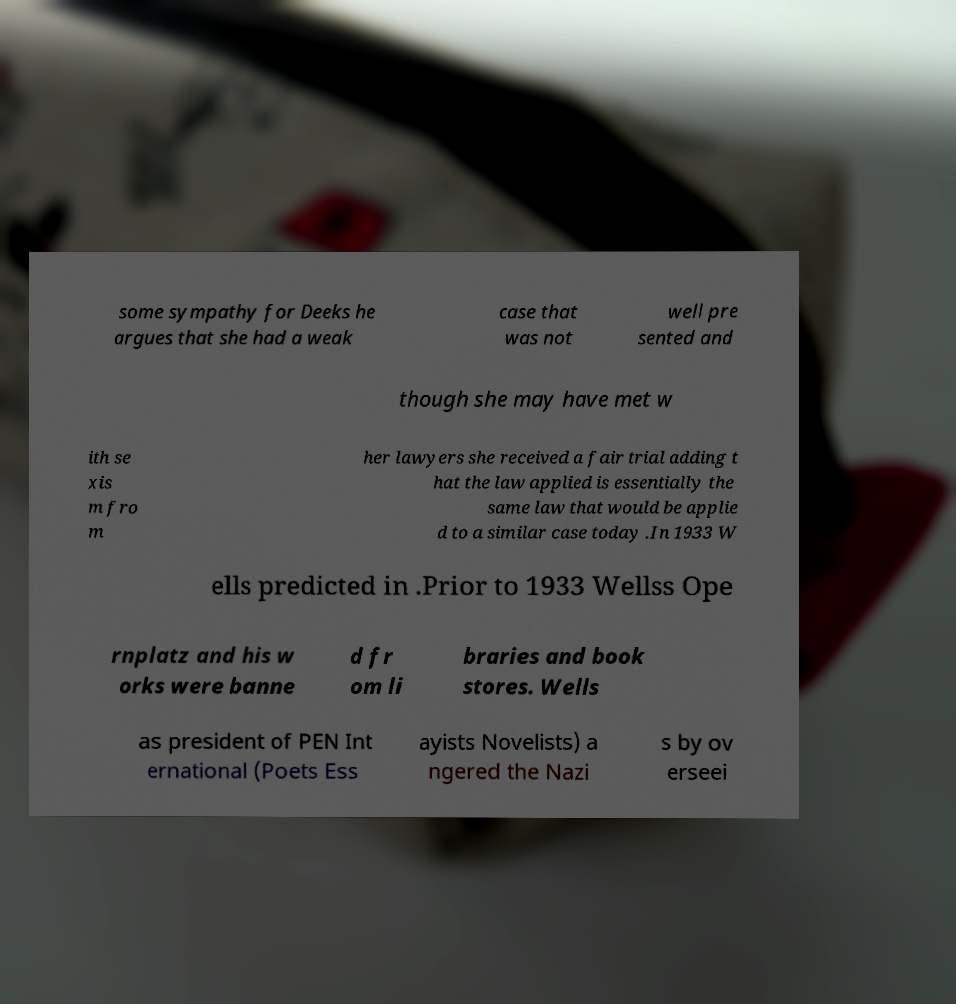Can you read and provide the text displayed in the image?This photo seems to have some interesting text. Can you extract and type it out for me? some sympathy for Deeks he argues that she had a weak case that was not well pre sented and though she may have met w ith se xis m fro m her lawyers she received a fair trial adding t hat the law applied is essentially the same law that would be applie d to a similar case today .In 1933 W ells predicted in .Prior to 1933 Wellss Ope rnplatz and his w orks were banne d fr om li braries and book stores. Wells as president of PEN Int ernational (Poets Ess ayists Novelists) a ngered the Nazi s by ov erseei 